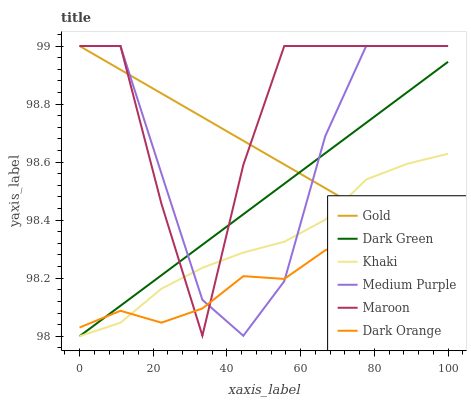Does Dark Orange have the minimum area under the curve?
Answer yes or no. Yes. Does Maroon have the maximum area under the curve?
Answer yes or no. Yes. Does Khaki have the minimum area under the curve?
Answer yes or no. No. Does Khaki have the maximum area under the curve?
Answer yes or no. No. Is Gold the smoothest?
Answer yes or no. Yes. Is Maroon the roughest?
Answer yes or no. Yes. Is Khaki the smoothest?
Answer yes or no. No. Is Khaki the roughest?
Answer yes or no. No. Does Khaki have the lowest value?
Answer yes or no. Yes. Does Gold have the lowest value?
Answer yes or no. No. Does Medium Purple have the highest value?
Answer yes or no. Yes. Does Khaki have the highest value?
Answer yes or no. No. Does Dark Green intersect Gold?
Answer yes or no. Yes. Is Dark Green less than Gold?
Answer yes or no. No. Is Dark Green greater than Gold?
Answer yes or no. No. 